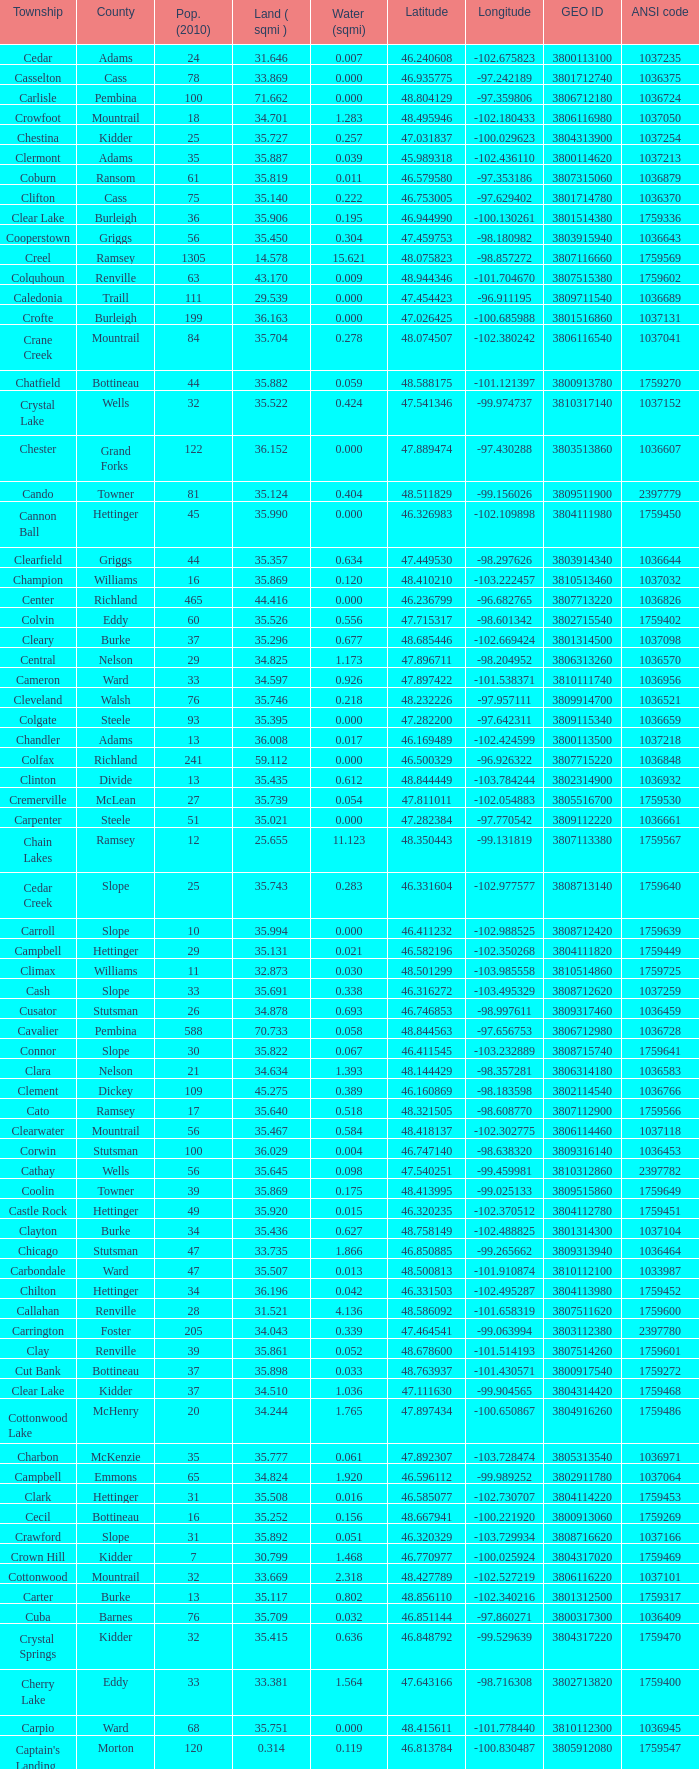What was the land area in sqmi that has a latitude of 48.763937? 35.898. 